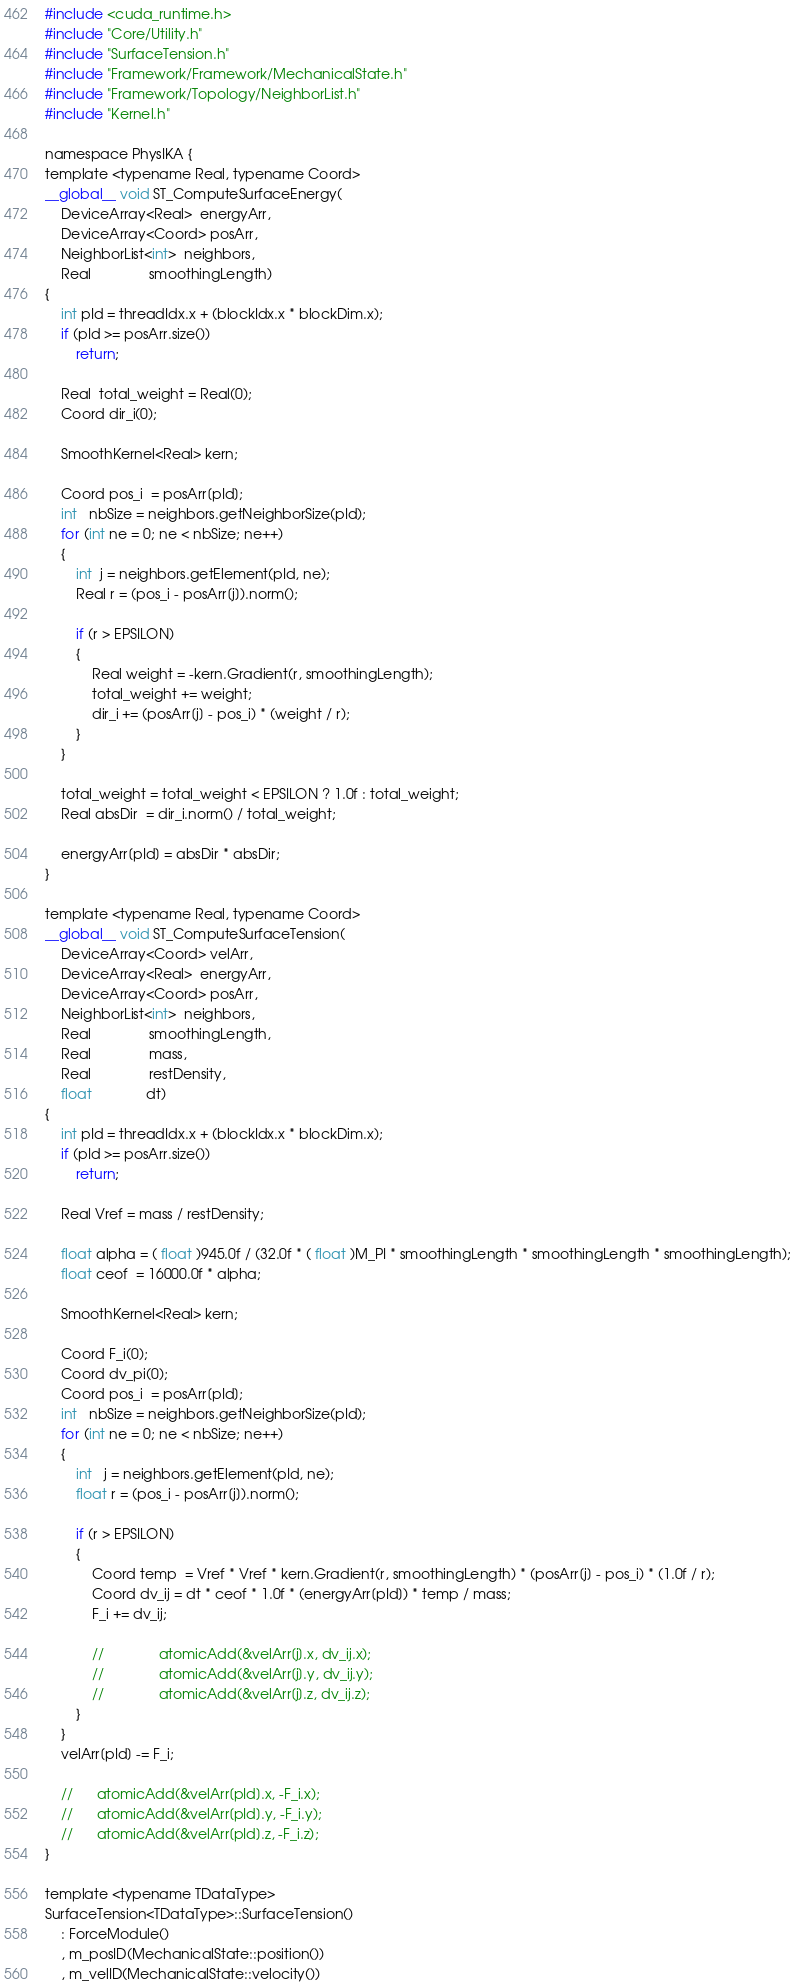<code> <loc_0><loc_0><loc_500><loc_500><_Cuda_>#include <cuda_runtime.h>
#include "Core/Utility.h"
#include "SurfaceTension.h"
#include "Framework/Framework/MechanicalState.h"
#include "Framework/Topology/NeighborList.h"
#include "Kernel.h"

namespace PhysIKA {
template <typename Real, typename Coord>
__global__ void ST_ComputeSurfaceEnergy(
    DeviceArray<Real>  energyArr,
    DeviceArray<Coord> posArr,
    NeighborList<int>  neighbors,
    Real               smoothingLength)
{
    int pId = threadIdx.x + (blockIdx.x * blockDim.x);
    if (pId >= posArr.size())
        return;

    Real  total_weight = Real(0);
    Coord dir_i(0);

    SmoothKernel<Real> kern;

    Coord pos_i  = posArr[pId];
    int   nbSize = neighbors.getNeighborSize(pId);
    for (int ne = 0; ne < nbSize; ne++)
    {
        int  j = neighbors.getElement(pId, ne);
        Real r = (pos_i - posArr[j]).norm();

        if (r > EPSILON)
        {
            Real weight = -kern.Gradient(r, smoothingLength);
            total_weight += weight;
            dir_i += (posArr[j] - pos_i) * (weight / r);
        }
    }

    total_weight = total_weight < EPSILON ? 1.0f : total_weight;
    Real absDir  = dir_i.norm() / total_weight;

    energyArr[pId] = absDir * absDir;
}

template <typename Real, typename Coord>
__global__ void ST_ComputeSurfaceTension(
    DeviceArray<Coord> velArr,
    DeviceArray<Real>  energyArr,
    DeviceArray<Coord> posArr,
    NeighborList<int>  neighbors,
    Real               smoothingLength,
    Real               mass,
    Real               restDensity,
    float              dt)
{
    int pId = threadIdx.x + (blockIdx.x * blockDim.x);
    if (pId >= posArr.size())
        return;

    Real Vref = mass / restDensity;

    float alpha = ( float )945.0f / (32.0f * ( float )M_PI * smoothingLength * smoothingLength * smoothingLength);
    float ceof  = 16000.0f * alpha;

    SmoothKernel<Real> kern;

    Coord F_i(0);
    Coord dv_pi(0);
    Coord pos_i  = posArr[pId];
    int   nbSize = neighbors.getNeighborSize(pId);
    for (int ne = 0; ne < nbSize; ne++)
    {
        int   j = neighbors.getElement(pId, ne);
        float r = (pos_i - posArr[j]).norm();

        if (r > EPSILON)
        {
            Coord temp  = Vref * Vref * kern.Gradient(r, smoothingLength) * (posArr[j] - pos_i) * (1.0f / r);
            Coord dv_ij = dt * ceof * 1.0f * (energyArr[pId]) * temp / mass;
            F_i += dv_ij;

            // 				atomicAdd(&velArr[j].x, dv_ij.x);
            // 				atomicAdd(&velArr[j].y, dv_ij.y);
            // 				atomicAdd(&velArr[j].z, dv_ij.z);
        }
    }
    velArr[pId] -= F_i;

    // 		atomicAdd(&velArr[pId].x, -F_i.x);
    // 		atomicAdd(&velArr[pId].y, -F_i.y);
    // 		atomicAdd(&velArr[pId].z, -F_i.z);
}

template <typename TDataType>
SurfaceTension<TDataType>::SurfaceTension()
    : ForceModule()
    , m_posID(MechanicalState::position())
    , m_velID(MechanicalState::velocity())</code> 